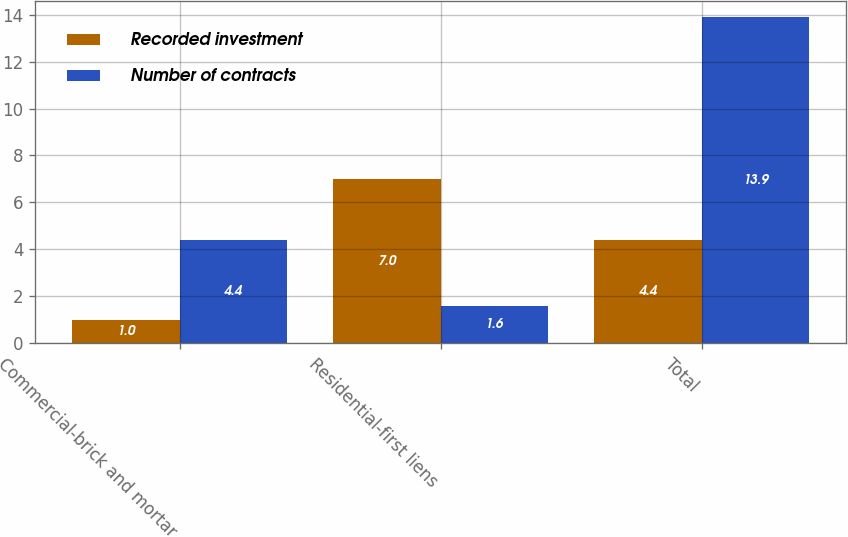Convert chart. <chart><loc_0><loc_0><loc_500><loc_500><stacked_bar_chart><ecel><fcel>Commercial-brick and mortar<fcel>Residential-first liens<fcel>Total<nl><fcel>Recorded investment<fcel>1<fcel>7<fcel>4.4<nl><fcel>Number of contracts<fcel>4.4<fcel>1.6<fcel>13.9<nl></chart> 